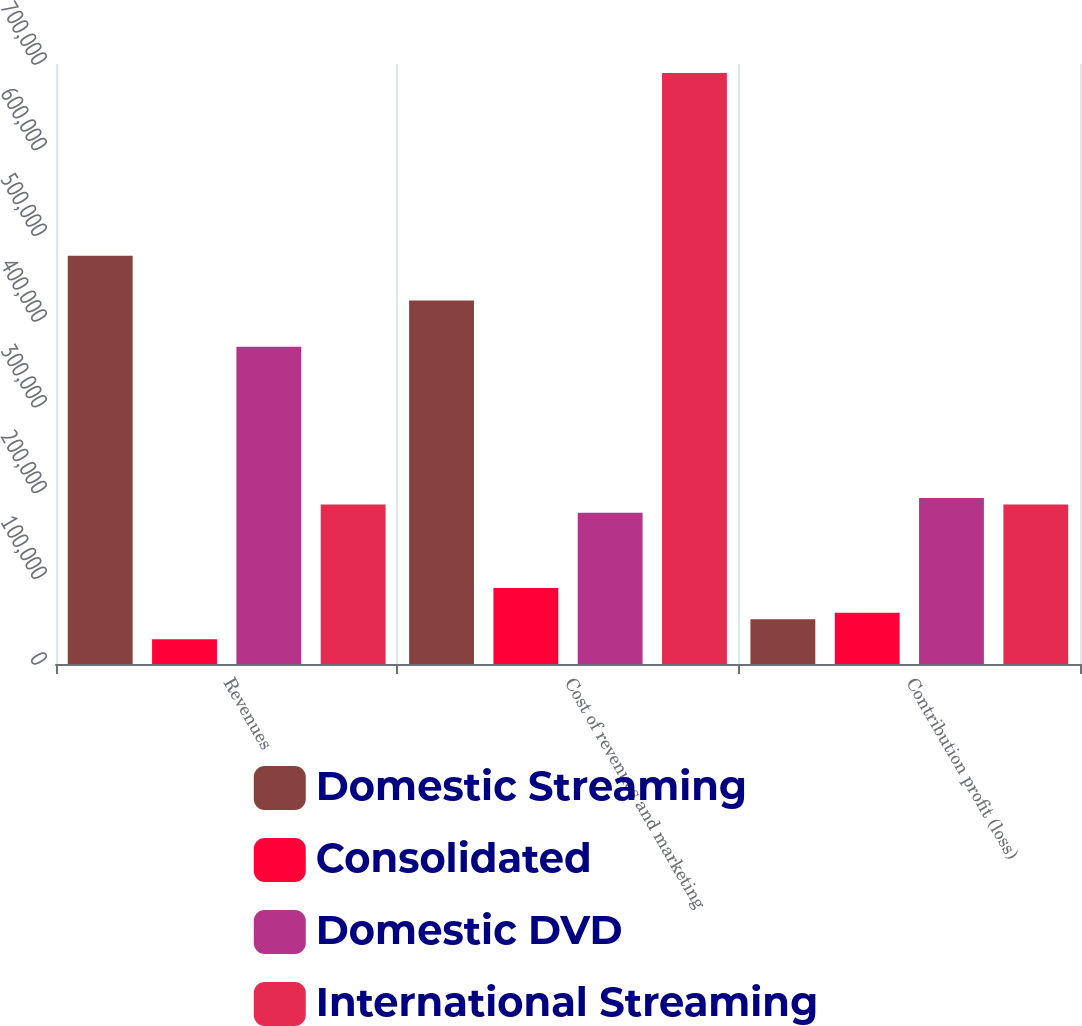Convert chart. <chart><loc_0><loc_0><loc_500><loc_500><stacked_bar_chart><ecel><fcel>Revenues<fcel>Cost of revenues and marketing<fcel>Contribution profit (loss)<nl><fcel>Domestic Streaming<fcel>476334<fcel>424224<fcel>52110<nl><fcel>Consolidated<fcel>28988<fcel>88731<fcel>59743<nl><fcel>Domestic DVD<fcel>370253<fcel>176488<fcel>193765<nl><fcel>International Streaming<fcel>186132<fcel>689443<fcel>186132<nl></chart> 